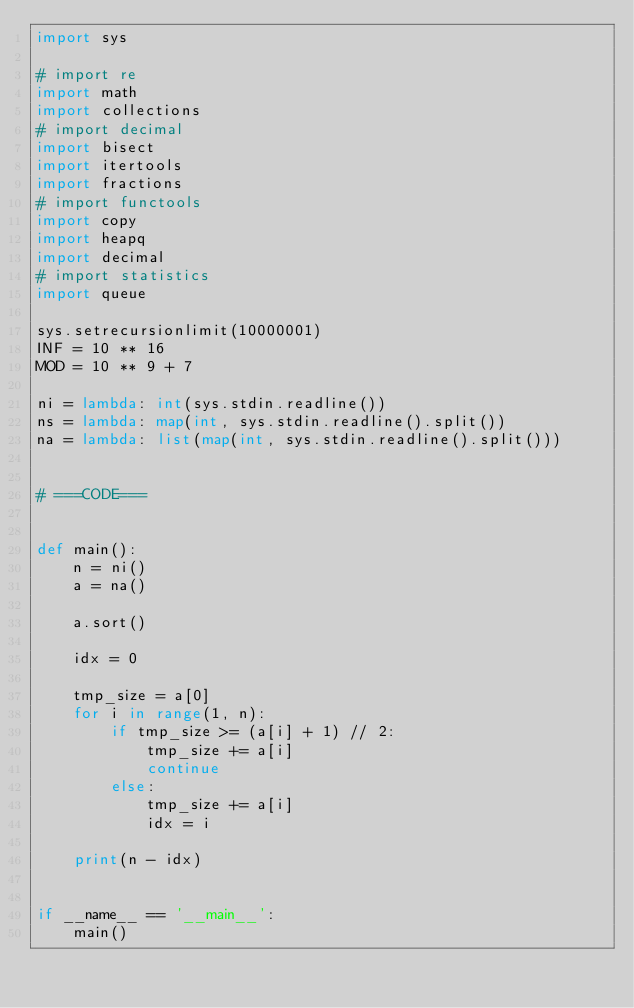Convert code to text. <code><loc_0><loc_0><loc_500><loc_500><_Python_>import sys

# import re
import math
import collections
# import decimal
import bisect
import itertools
import fractions
# import functools
import copy
import heapq
import decimal
# import statistics
import queue

sys.setrecursionlimit(10000001)
INF = 10 ** 16
MOD = 10 ** 9 + 7

ni = lambda: int(sys.stdin.readline())
ns = lambda: map(int, sys.stdin.readline().split())
na = lambda: list(map(int, sys.stdin.readline().split()))


# ===CODE===


def main():
    n = ni()
    a = na()

    a.sort()

    idx = 0

    tmp_size = a[0]
    for i in range(1, n):
        if tmp_size >= (a[i] + 1) // 2:
            tmp_size += a[i]
            continue
        else:
            tmp_size += a[i]
            idx = i

    print(n - idx)


if __name__ == '__main__':
    main()
</code> 